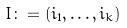<formula> <loc_0><loc_0><loc_500><loc_500>I \colon = ( i _ { 1 } , \dots , i _ { k } )</formula> 